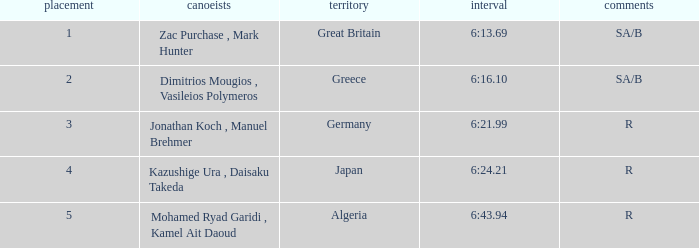What country is ranked #2? Greece. 